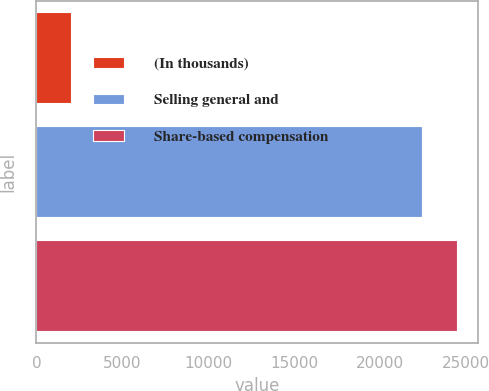Convert chart. <chart><loc_0><loc_0><loc_500><loc_500><bar_chart><fcel>(In thousands)<fcel>Selling general and<fcel>Share-based compensation<nl><fcel>2006<fcel>22436<fcel>24479<nl></chart> 